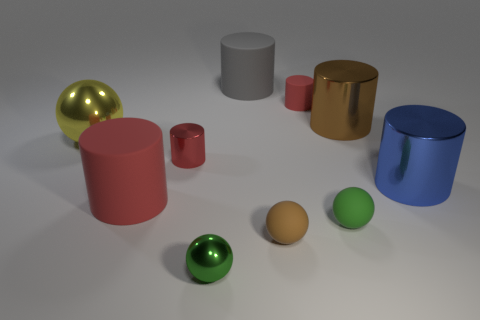Subtract all cyan balls. How many red cylinders are left? 3 Subtract all brown metal cylinders. How many cylinders are left? 5 Subtract all brown cylinders. How many cylinders are left? 5 Subtract all brown cylinders. Subtract all cyan balls. How many cylinders are left? 5 Subtract all balls. How many objects are left? 6 Subtract all gray matte cylinders. Subtract all small shiny things. How many objects are left? 7 Add 7 big yellow metallic things. How many big yellow metallic things are left? 8 Add 6 green metallic objects. How many green metallic objects exist? 7 Subtract 0 gray cubes. How many objects are left? 10 